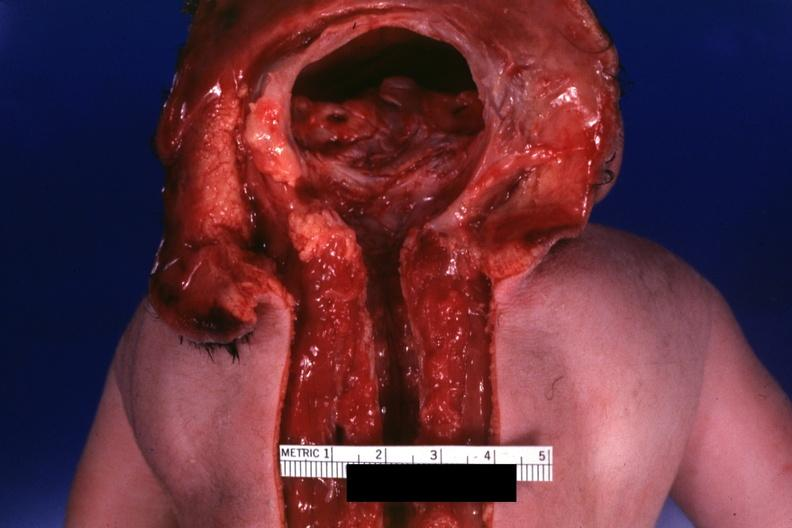what is present?
Answer the question using a single word or phrase. Brain 